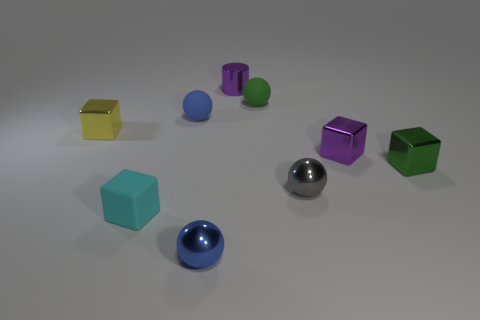Subtract all purple shiny blocks. How many blocks are left? 3 Subtract all purple cubes. How many cubes are left? 3 Add 1 tiny yellow metallic cylinders. How many objects exist? 10 Subtract all blocks. How many objects are left? 5 Subtract 1 cylinders. How many cylinders are left? 0 Subtract all brown cylinders. How many yellow cubes are left? 1 Subtract all small gray metal balls. Subtract all purple cylinders. How many objects are left? 7 Add 6 tiny cyan things. How many tiny cyan things are left? 7 Add 1 large brown rubber blocks. How many large brown rubber blocks exist? 1 Subtract 0 brown spheres. How many objects are left? 9 